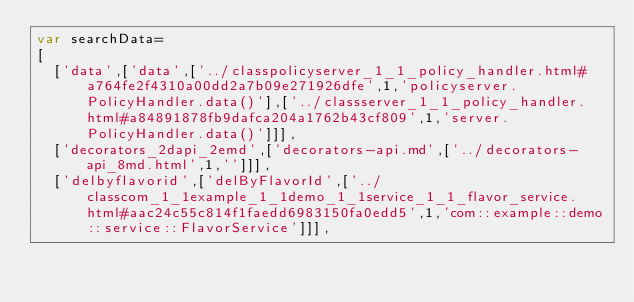Convert code to text. <code><loc_0><loc_0><loc_500><loc_500><_JavaScript_>var searchData=
[
  ['data',['data',['../classpolicyserver_1_1_policy_handler.html#a764fe2f4310a00dd2a7b09e271926dfe',1,'policyserver.PolicyHandler.data()'],['../classserver_1_1_policy_handler.html#a84891878fb9dafca204a1762b43cf809',1,'server.PolicyHandler.data()']]],
  ['decorators_2dapi_2emd',['decorators-api.md',['../decorators-api_8md.html',1,'']]],
  ['delbyflavorid',['delByFlavorId',['../classcom_1_1example_1_1demo_1_1service_1_1_flavor_service.html#aac24c55c814f1faedd6983150fa0edd5',1,'com::example::demo::service::FlavorService']]],</code> 